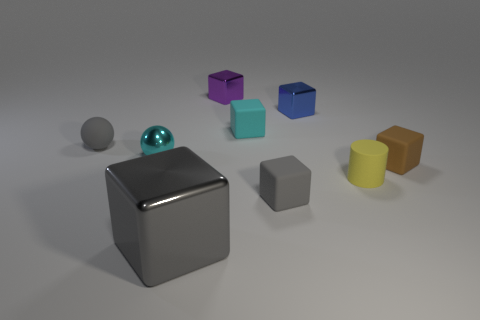Subtract all purple cubes. How many cubes are left? 5 Subtract all gray shiny blocks. How many blocks are left? 5 Subtract all cyan cubes. Subtract all gray cylinders. How many cubes are left? 5 Add 1 small cylinders. How many objects exist? 10 Subtract all spheres. How many objects are left? 7 Add 2 tiny blocks. How many tiny blocks exist? 7 Subtract 0 brown cylinders. How many objects are left? 9 Subtract all blue things. Subtract all yellow rubber balls. How many objects are left? 8 Add 2 rubber spheres. How many rubber spheres are left? 3 